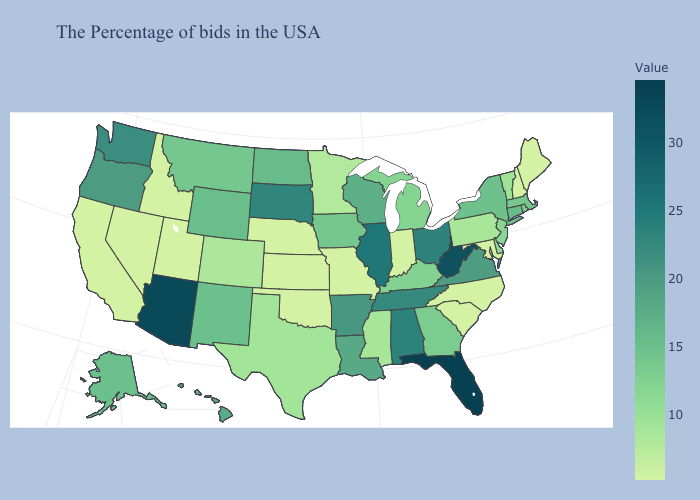Which states hav the highest value in the West?
Concise answer only. Arizona. Among the states that border Missouri , which have the lowest value?
Keep it brief. Kansas, Nebraska, Oklahoma. Is the legend a continuous bar?
Short answer required. Yes. Does California have the lowest value in the West?
Keep it brief. Yes. Among the states that border Florida , does Georgia have the highest value?
Keep it brief. No. Does Oregon have the highest value in the West?
Concise answer only. No. 